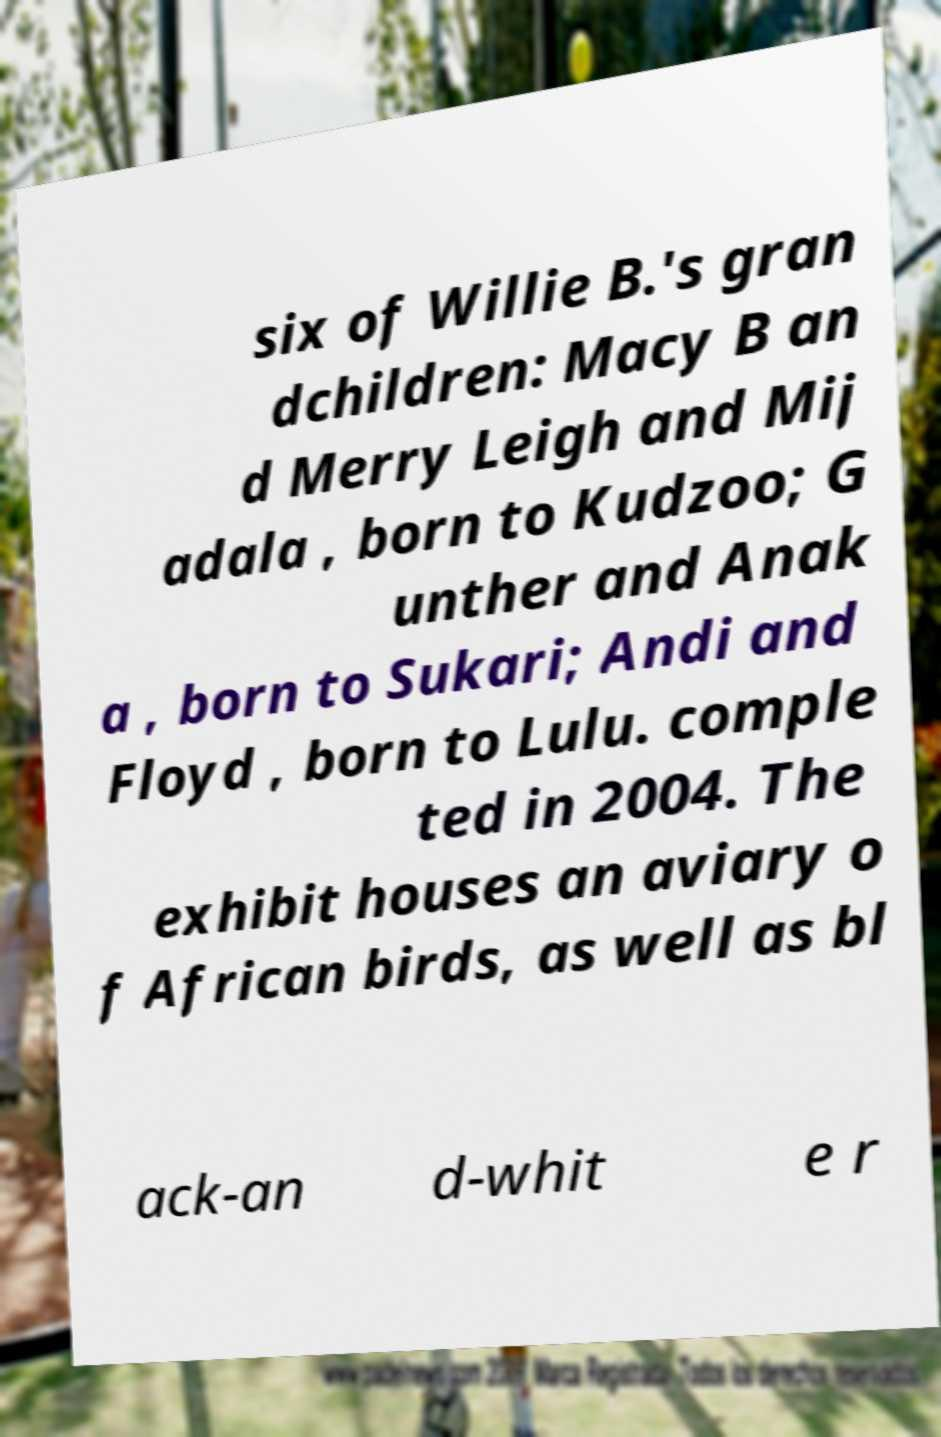Can you read and provide the text displayed in the image?This photo seems to have some interesting text. Can you extract and type it out for me? six of Willie B.'s gran dchildren: Macy B an d Merry Leigh and Mij adala , born to Kudzoo; G unther and Anak a , born to Sukari; Andi and Floyd , born to Lulu. comple ted in 2004. The exhibit houses an aviary o f African birds, as well as bl ack-an d-whit e r 